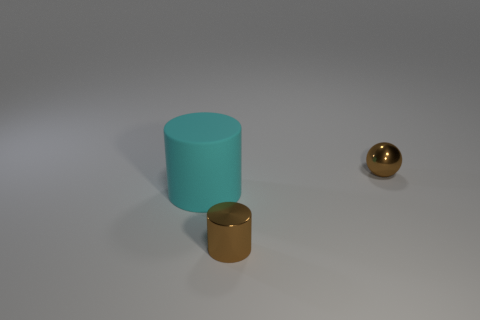Add 1 small blue matte cylinders. How many objects exist? 4 Subtract all cylinders. How many objects are left? 1 Add 1 brown metal objects. How many brown metal objects are left? 3 Add 1 brown rubber cylinders. How many brown rubber cylinders exist? 1 Subtract 0 green cylinders. How many objects are left? 3 Subtract all shiny balls. Subtract all big cyan matte cylinders. How many objects are left? 1 